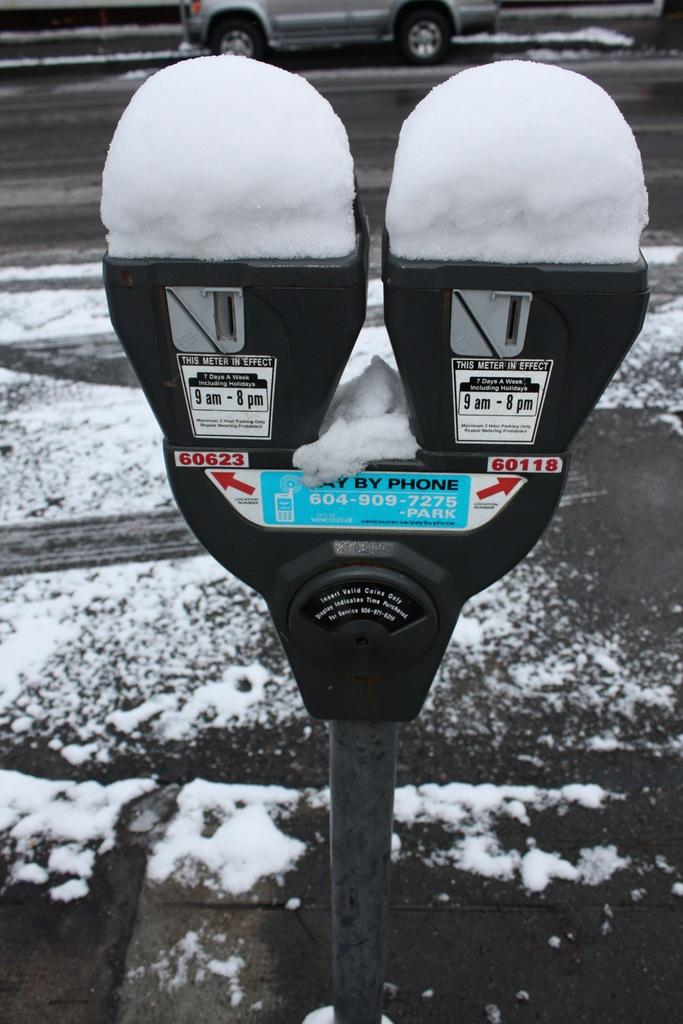<image>
Summarize the visual content of the image. A parking meter that is in effect seven days a week with snow over the dials. 